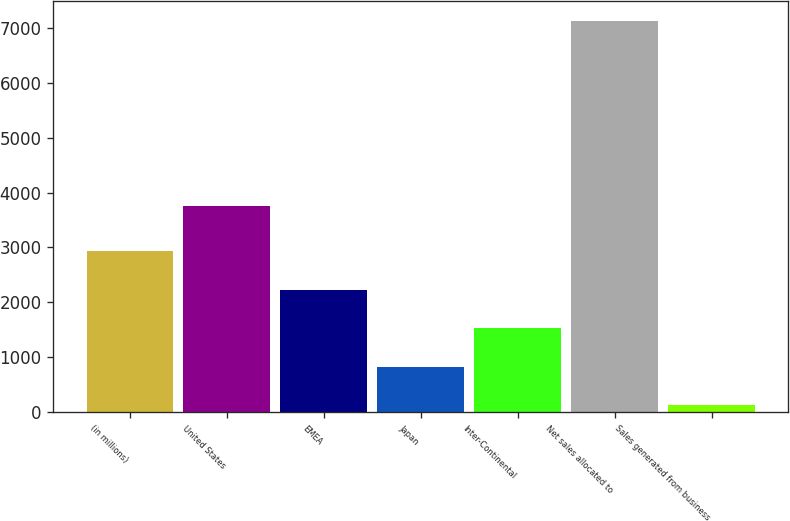Convert chart to OTSL. <chart><loc_0><loc_0><loc_500><loc_500><bar_chart><fcel>(in millions)<fcel>United States<fcel>EMEA<fcel>Japan<fcel>Inter-Continental<fcel>Net sales allocated to<fcel>Sales generated from business<nl><fcel>2928.5<fcel>3756<fcel>2228<fcel>827<fcel>1527.5<fcel>7127<fcel>122<nl></chart> 